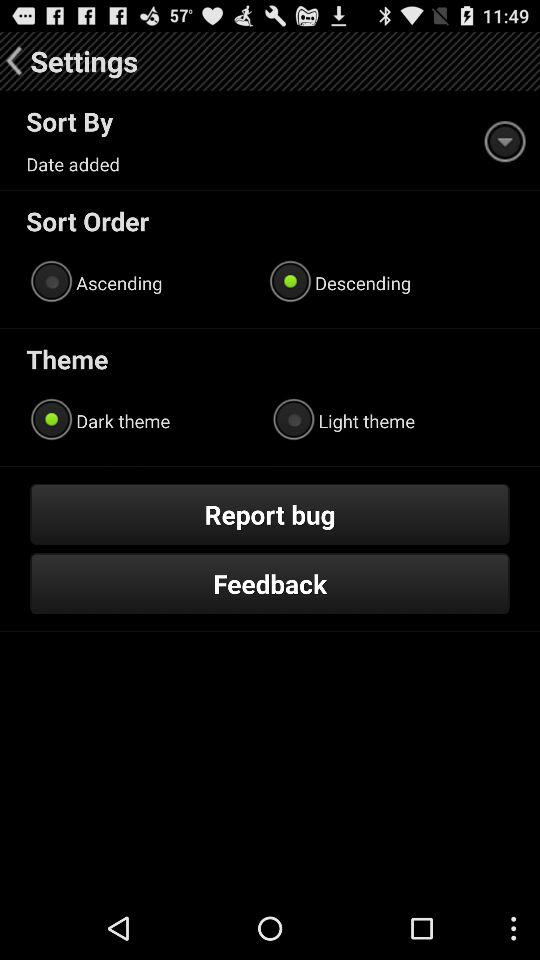Which sort order has been selected? The selected sort order is "Descending". 